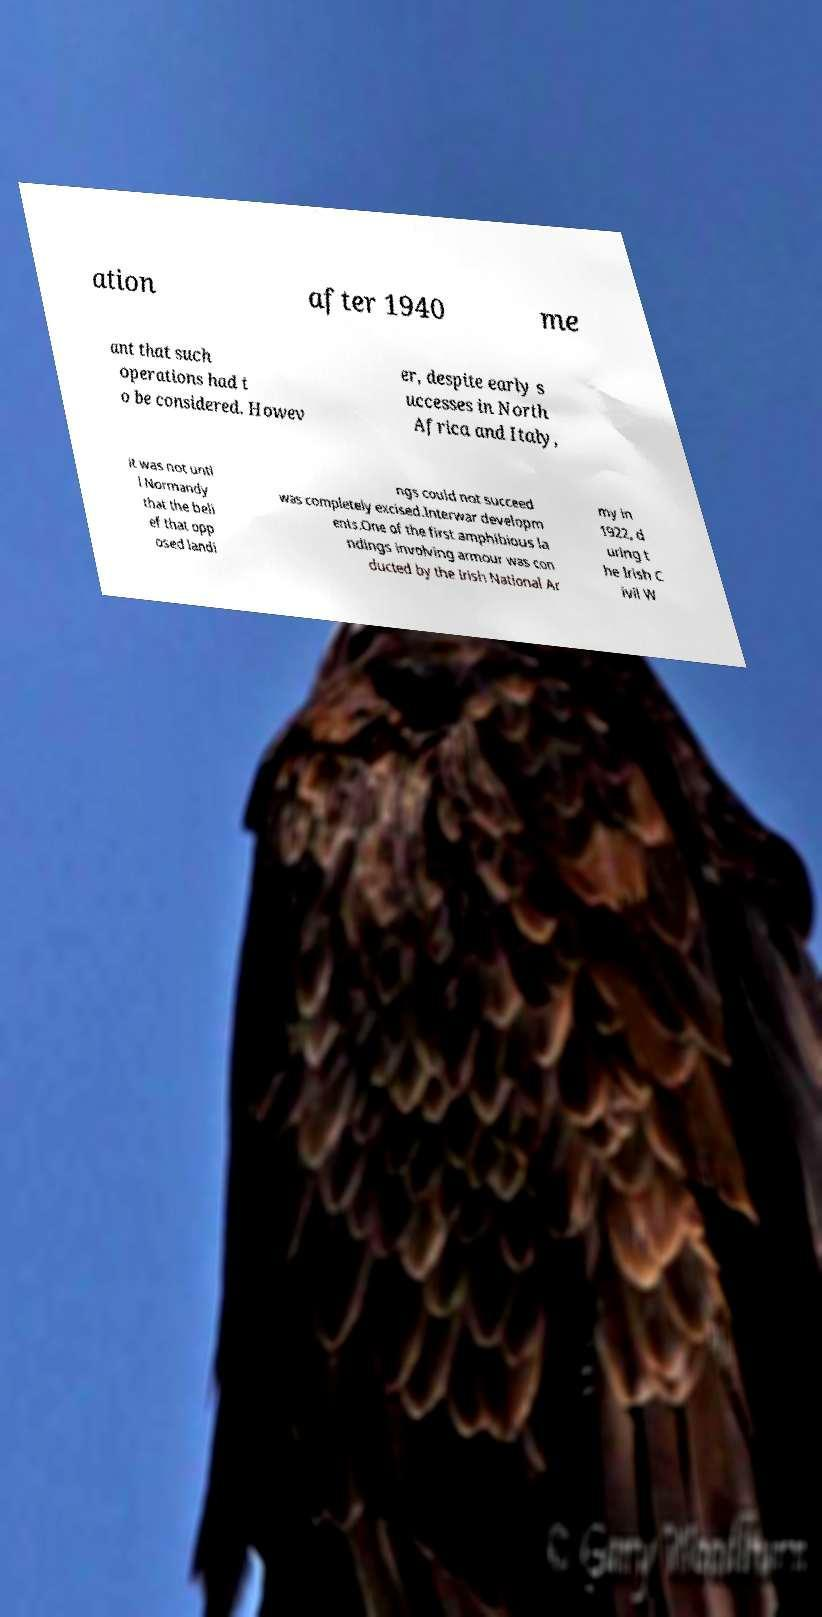There's text embedded in this image that I need extracted. Can you transcribe it verbatim? ation after 1940 me ant that such operations had t o be considered. Howev er, despite early s uccesses in North Africa and Italy, it was not unti l Normandy that the beli ef that opp osed landi ngs could not succeed was completely excised.Interwar developm ents.One of the first amphibious la ndings involving armour was con ducted by the Irish National Ar my in 1922, d uring t he Irish C ivil W 